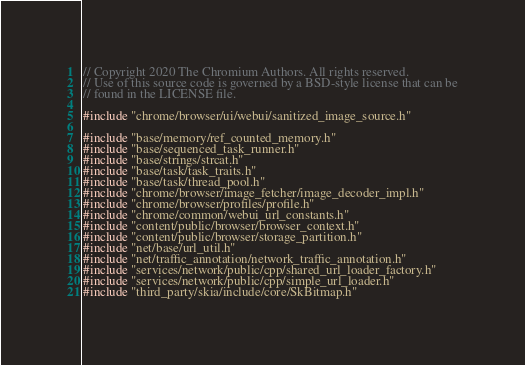<code> <loc_0><loc_0><loc_500><loc_500><_C++_>// Copyright 2020 The Chromium Authors. All rights reserved.
// Use of this source code is governed by a BSD-style license that can be
// found in the LICENSE file.

#include "chrome/browser/ui/webui/sanitized_image_source.h"

#include "base/memory/ref_counted_memory.h"
#include "base/sequenced_task_runner.h"
#include "base/strings/strcat.h"
#include "base/task/task_traits.h"
#include "base/task/thread_pool.h"
#include "chrome/browser/image_fetcher/image_decoder_impl.h"
#include "chrome/browser/profiles/profile.h"
#include "chrome/common/webui_url_constants.h"
#include "content/public/browser/browser_context.h"
#include "content/public/browser/storage_partition.h"
#include "net/base/url_util.h"
#include "net/traffic_annotation/network_traffic_annotation.h"
#include "services/network/public/cpp/shared_url_loader_factory.h"
#include "services/network/public/cpp/simple_url_loader.h"
#include "third_party/skia/include/core/SkBitmap.h"</code> 